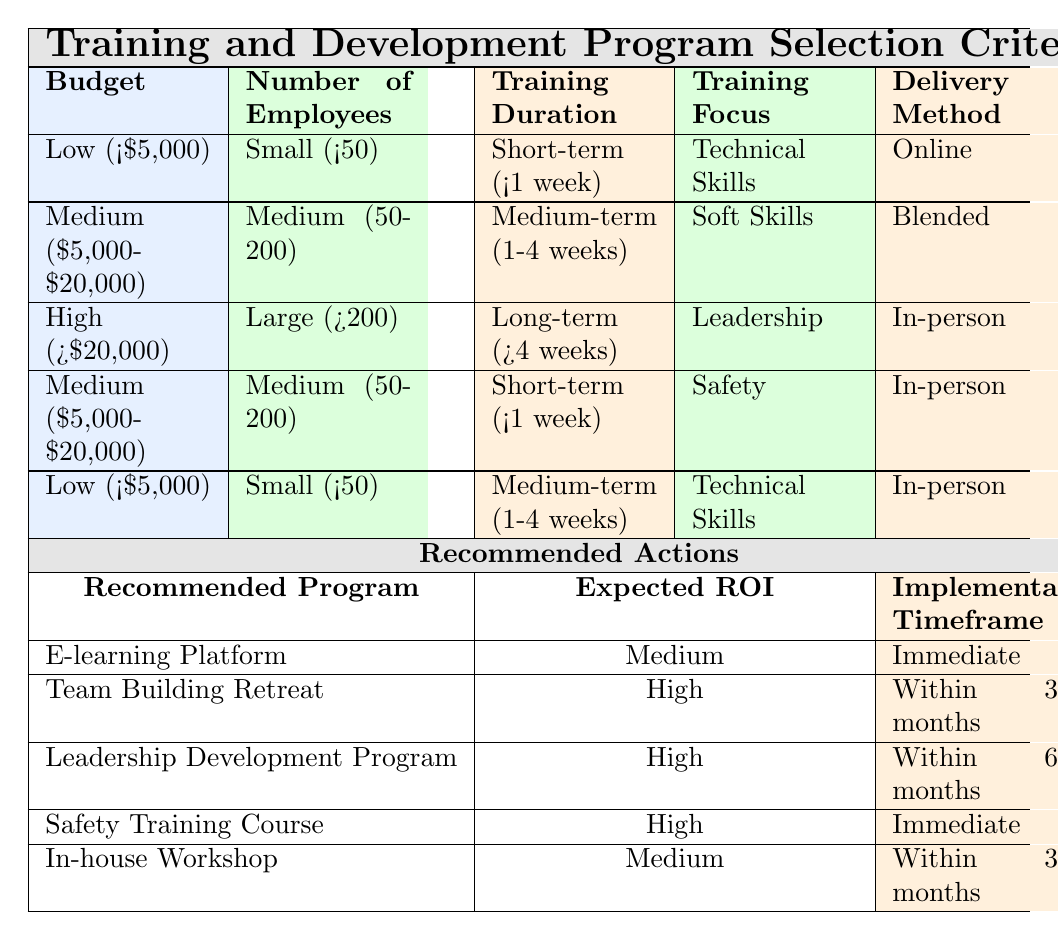What is the recommended program for a low budget with a small number of employees focused on technical skills? According to the table, for a budget of Low (<$5,000), with Small (<50) employees and a focus on Technical Skills, the recommended program is the E-learning Platform.
Answer: E-learning Platform What is the expected ROI for the Leadership Development Program? The table indicates that for the Leadership Development Program, which is categorized under High (>$20,000) budget, Large (>200) employees, Long-term (>4 weeks) training duration, and Leadership focus, the expected ROI is High.
Answer: High Are there any programs that have an immediate implementation timeframe? From the table, the two programs with an immediate implementation timeframe are the E-learning Platform and the Safety Training Course, both listed under their respective conditions.
Answer: Yes How many programs recommend a training duration of less than one week? By analyzing the table, there are two programs that recommend a training duration of Short-term (<1 week): the E-learning Platform and the Safety Training Course. Thus, the total count is 2.
Answer: 2 What is the expected ROI for programs aimed at soft skills training? The only program that focuses on Soft Skills training is the Team Building Retreat, which has an expected ROI categorized as High.
Answer: High What is the average implementation timeframe for programs targeting Medium-sized companies with a Medium budget? The applicable programs for Medium-sized companies (50-200 employees) and Medium budget ($5,000-$20,000) are the Team Building Retreat and the Safety Training Course, which have timeframes of Within 3 months (Team Building Retreat) and Immediate (Safety Training Course). Calculating the average as Immediate (0 months) and Within 3 months gives us a total of 3 months for averaging. Since there are two programs, the average is 3 months / 2 = 1.5 months, and the final answer is Within 2 months as an approximation.
Answer: Within 2 months Which delivery method is most common among the recommended programs? By examining the delivery methods in the table, we find that there are two programs delivered Online (E-learning Platform) and two programs delivered In-person (Safety Training Course and Leadership Development Program). However, there is one program that uses the Blended delivery method (Team Building Retreat). Since In-person is repeated, the most common delivery method is In-person.
Answer: In-person Is a professional certification recommended for low-budget training? The table shows that there are no recommended programs specifically labeled as Professional Certification within the conditions for Low budget training. The recommended options primarily include E-learning Platform and In-house Workshop. Therefore, there is no Professional Certification suggested for low budgets.
Answer: No 